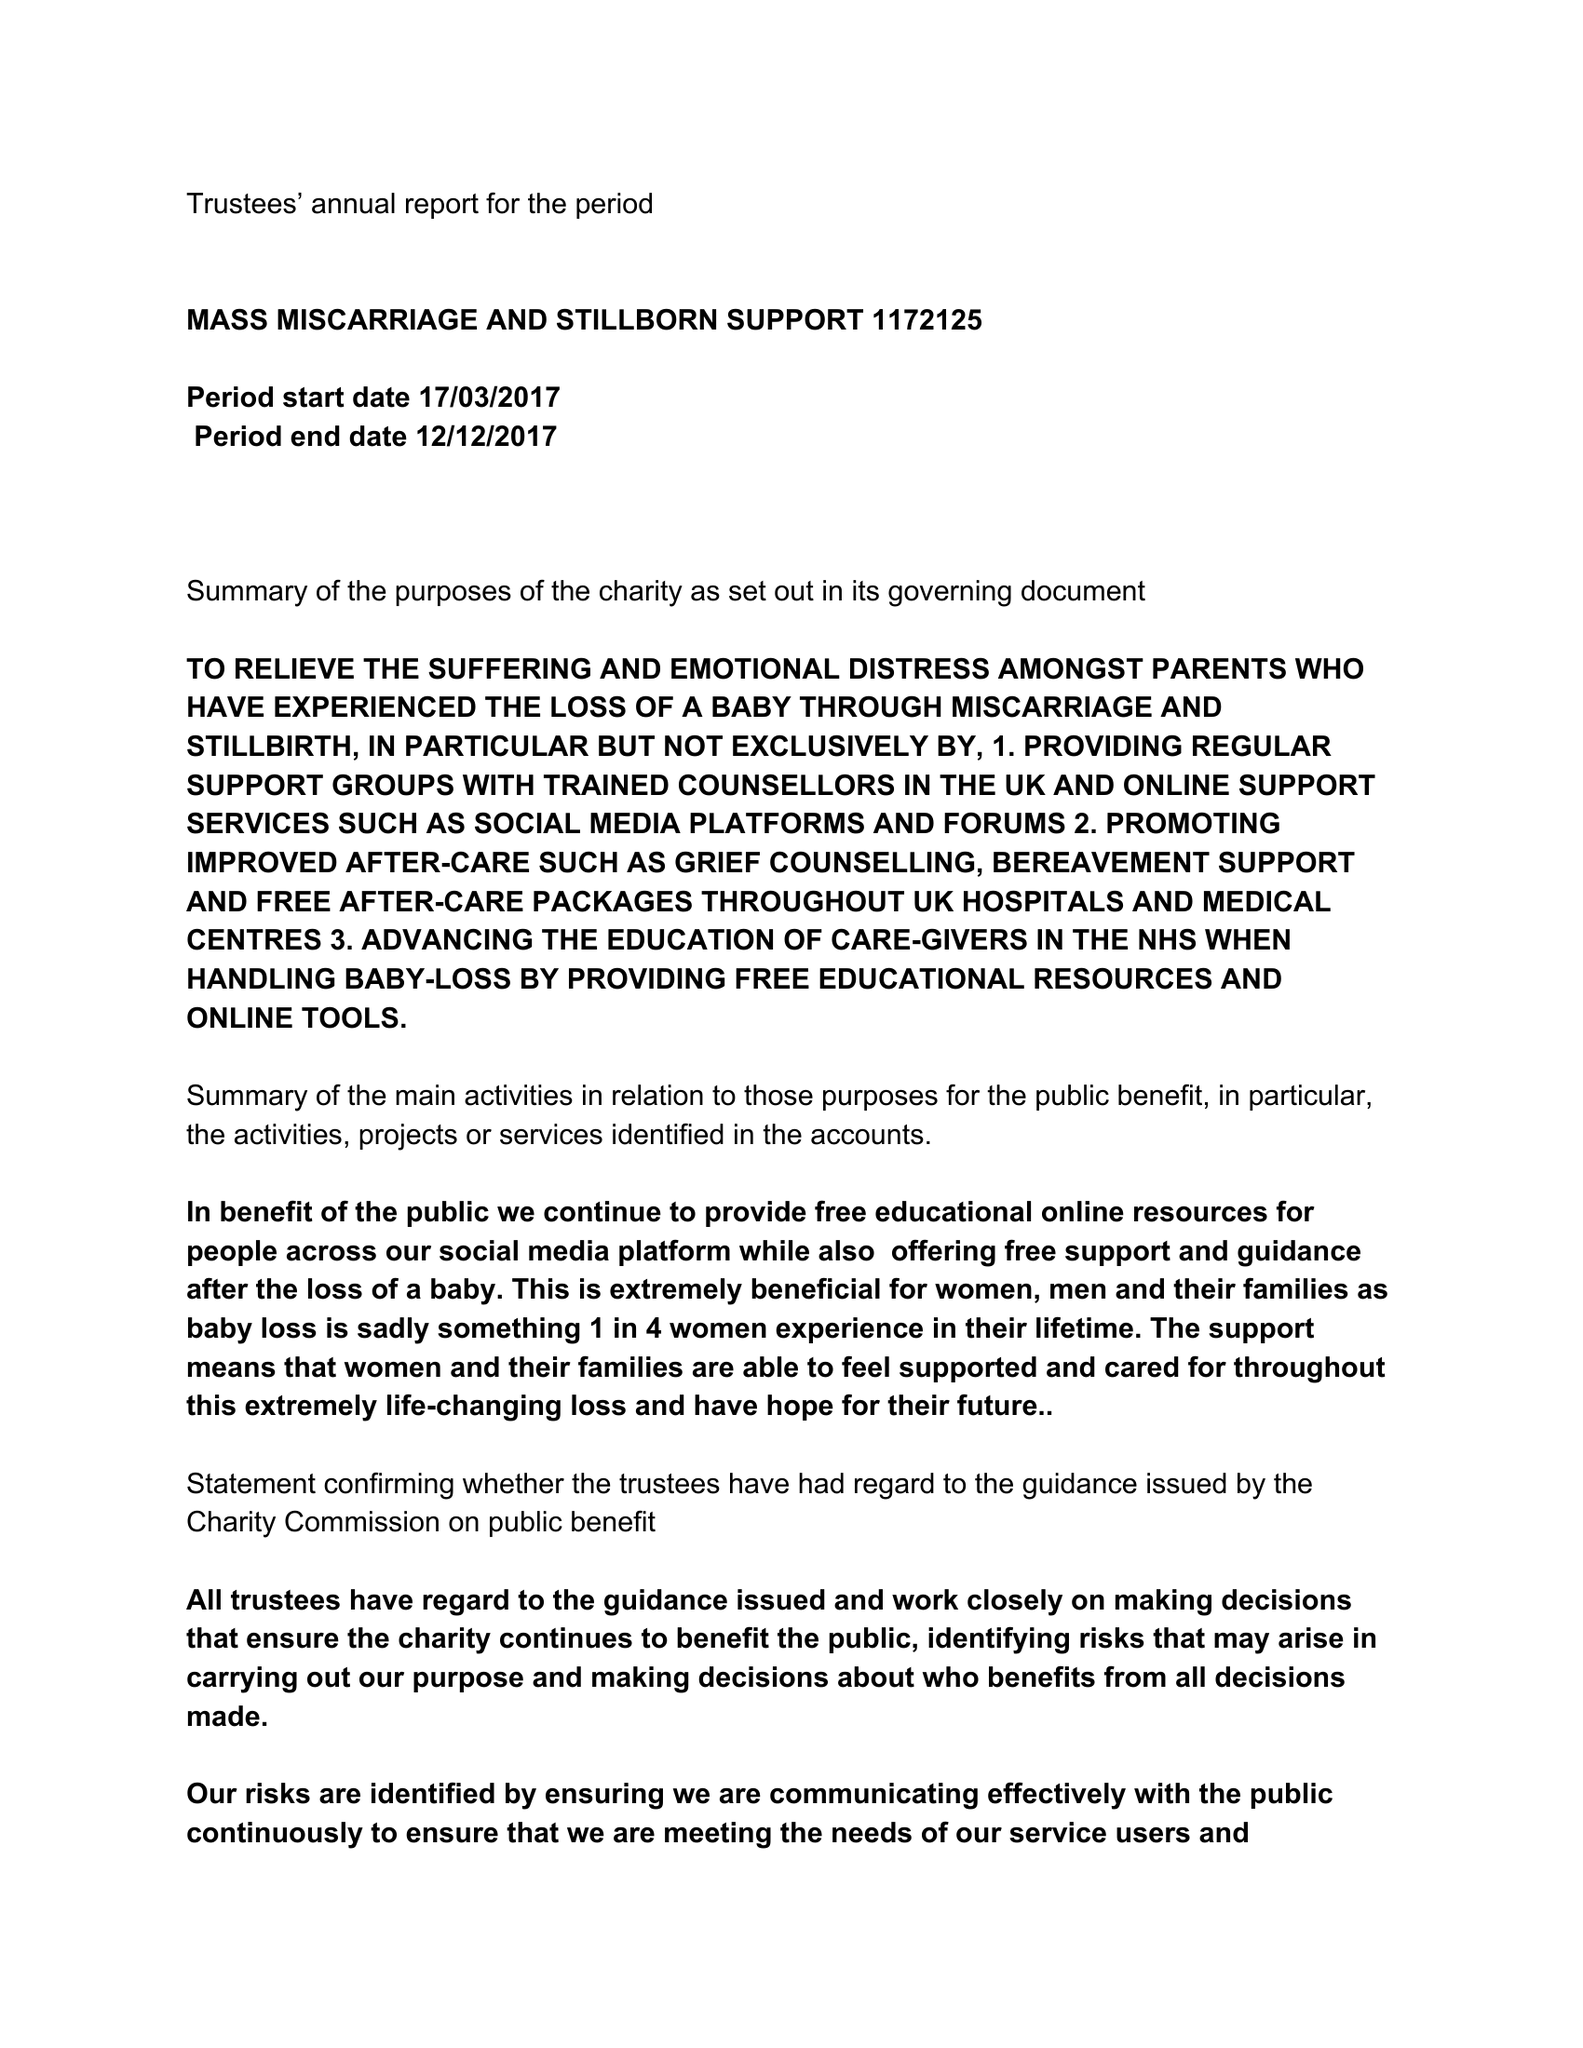What is the value for the charity_number?
Answer the question using a single word or phrase. 1172125 